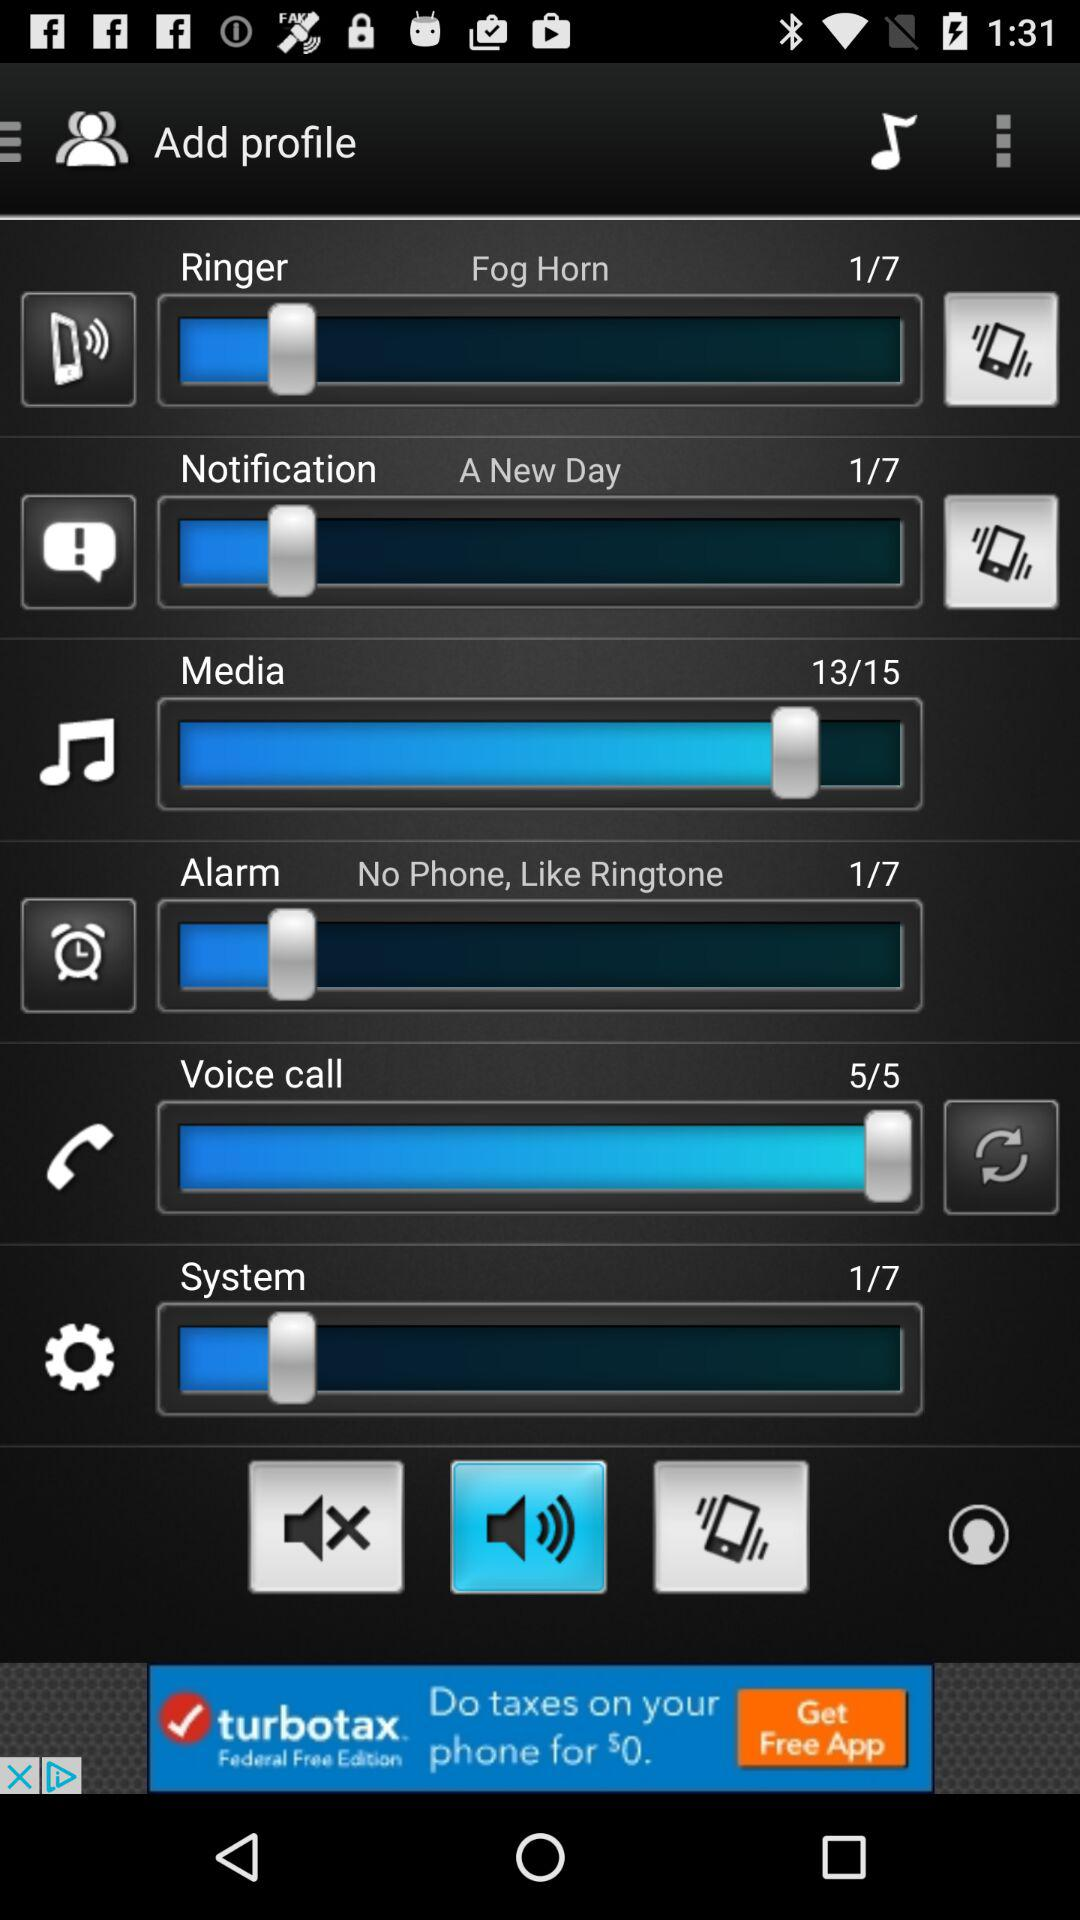How loud is the system volume? The system volume is 1. 